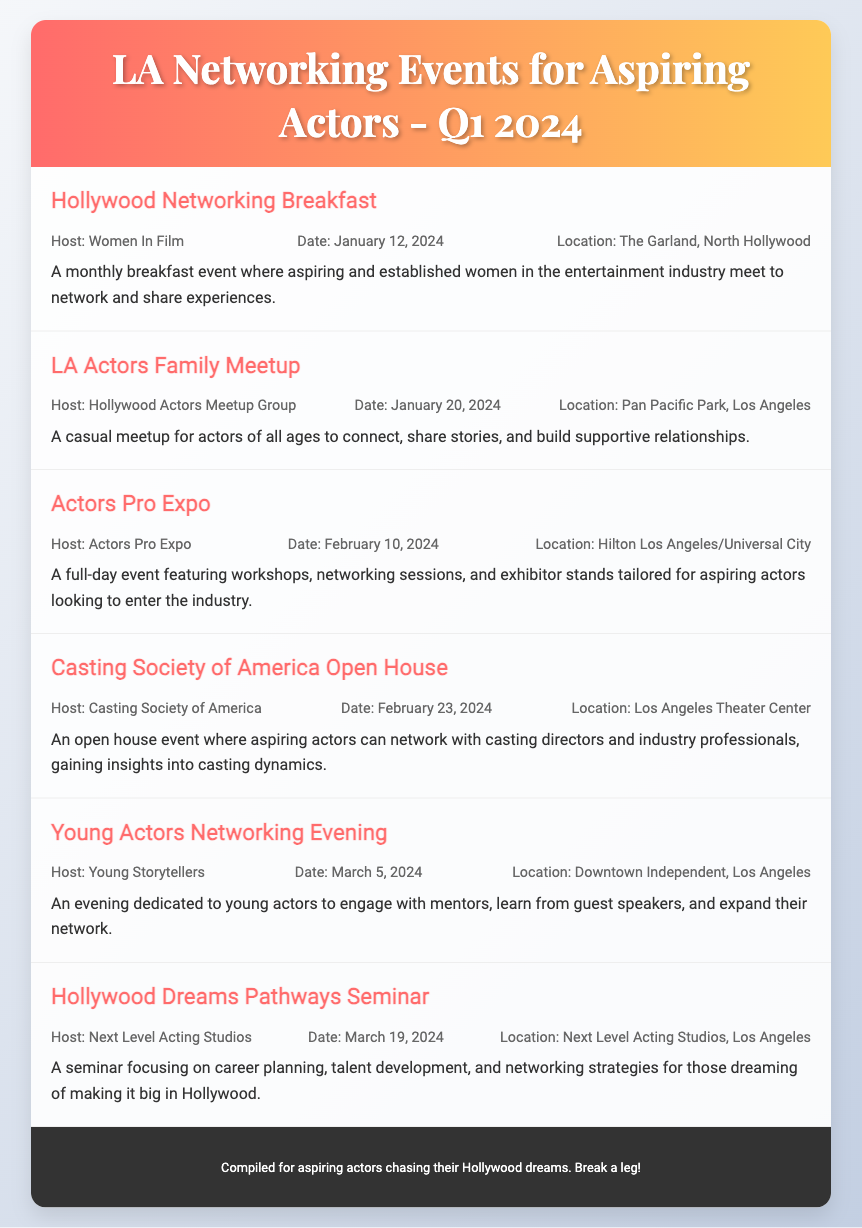What is the first event listed? The first event in the document is "Hollywood Networking Breakfast."
Answer: Hollywood Networking Breakfast When is the LA Actors Family Meetup scheduled? The LA Actors Family Meetup is scheduled for January 20, 2024.
Answer: January 20, 2024 Where will the Actors Pro Expo take place? The Actors Pro Expo will take place at Hilton Los Angeles/Universal City.
Answer: Hilton Los Angeles/Universal City Who is hosting the Hollywood Dreams Pathways Seminar? The seminar is hosted by Next Level Acting Studios.
Answer: Next Level Acting Studios How many networking events are there in March 2024? There are two networking events listed for March 2024.
Answer: 2 Which event allows networking with casting directors? The event that allows networking with casting directors is the "Casting Society of America Open House."
Answer: Casting Society of America Open House What type of event is the "Young Actors Networking Evening"? The "Young Actors Networking Evening" is dedicated to young actors.
Answer: Dedicated to young actors What is the primary focus of the Hollywood Dreams Pathways Seminar? The primary focus of the seminar is career planning, talent development, and networking strategies.
Answer: Career planning, talent development, and networking strategies 